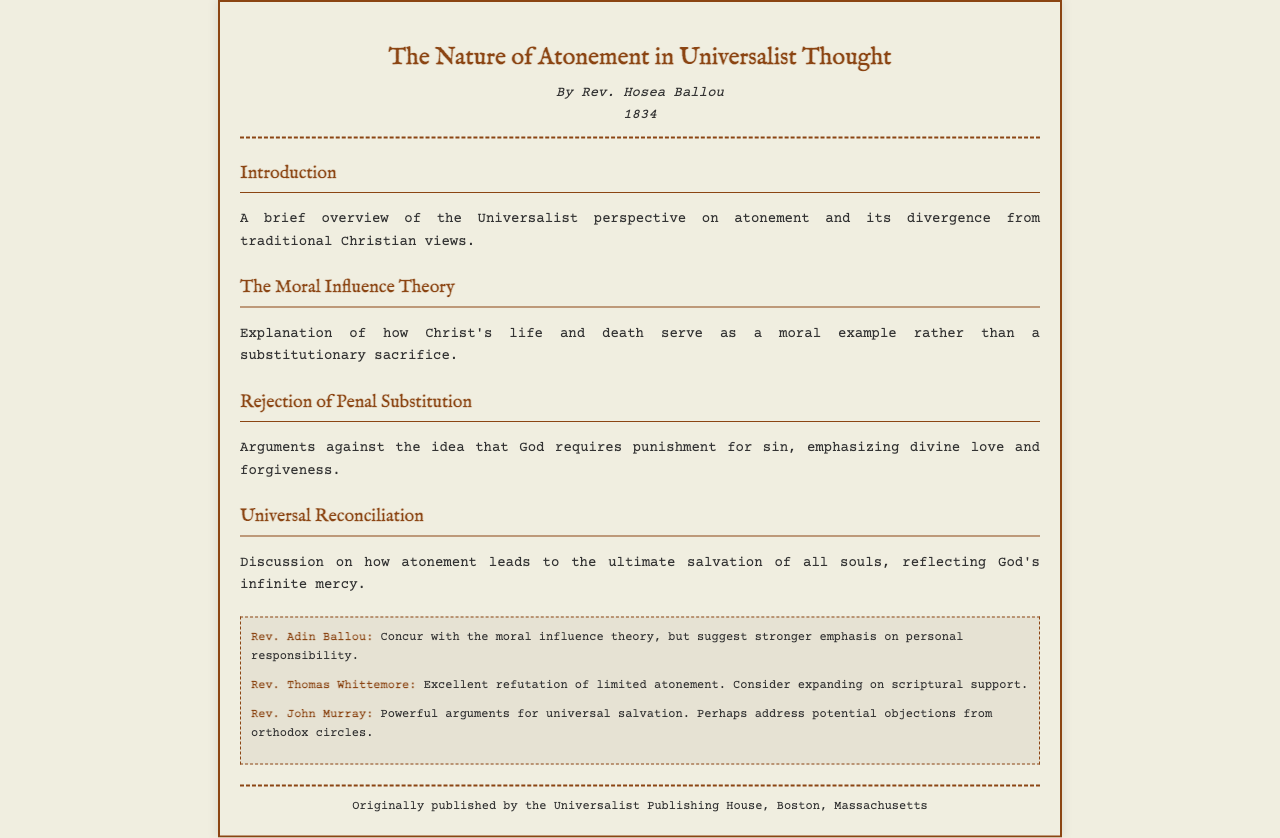What is the title of the pamphlet? The title of the pamphlet is located at the top of the document.
Answer: The Nature of Atonement in Universalist Thought Who is the author of the pamphlet? The author's name is stated right under the title in the fax.
Answer: Rev. Hosea Ballou In what year was the pamphlet published? The publication year is provided beneath the author's name in the header.
Answer: 1834 What theory is explained in the second section? The second section discusses a specific theory mentioned in the headings of the document.
Answer: The Moral Influence Theory Which theologian suggested a stronger emphasis on personal responsibility? The name of the theologian making this suggestion is mentioned in the annotations section.
Answer: Rev. Adin Ballou What is a key argument rejected in the pamphlet? The document specifically mentions a key argument that is addressed and refuted.
Answer: Penal Substitution What does the pamphlet emphasize regarding God's nature in the context of atonement? The pamphlet emphasizes a specific attribute of God regarding atonement, clearly stated in the sections.
Answer: Divine love and forgiveness Which annotator discussed potential objections from orthodox circles? The name of the annotator discussing this topic is found in the annotations section.
Answer: Rev. John Murray 